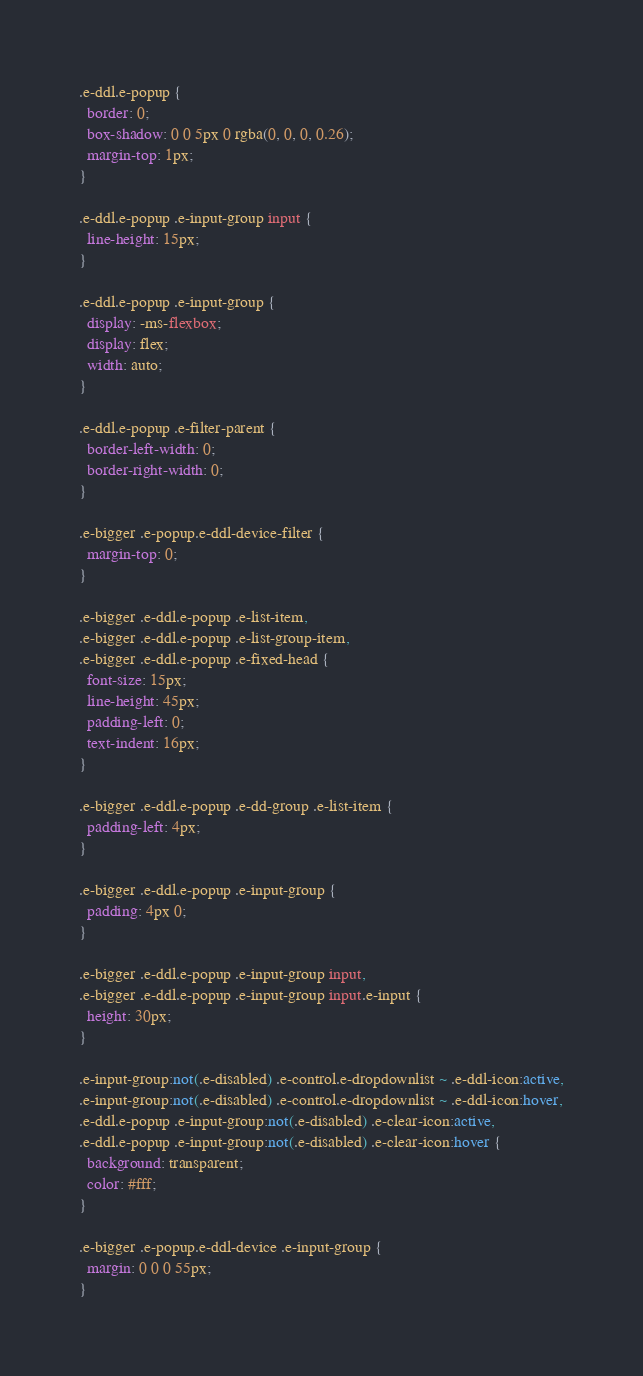Convert code to text. <code><loc_0><loc_0><loc_500><loc_500><_CSS_>.e-ddl.e-popup {
  border: 0;
  box-shadow: 0 0 5px 0 rgba(0, 0, 0, 0.26);
  margin-top: 1px;
}

.e-ddl.e-popup .e-input-group input {
  line-height: 15px;
}

.e-ddl.e-popup .e-input-group {
  display: -ms-flexbox;
  display: flex;
  width: auto;
}

.e-ddl.e-popup .e-filter-parent {
  border-left-width: 0;
  border-right-width: 0;
}

.e-bigger .e-popup.e-ddl-device-filter {
  margin-top: 0;
}

.e-bigger .e-ddl.e-popup .e-list-item,
.e-bigger .e-ddl.e-popup .e-list-group-item,
.e-bigger .e-ddl.e-popup .e-fixed-head {
  font-size: 15px;
  line-height: 45px;
  padding-left: 0;
  text-indent: 16px;
}

.e-bigger .e-ddl.e-popup .e-dd-group .e-list-item {
  padding-left: 4px;
}

.e-bigger .e-ddl.e-popup .e-input-group {
  padding: 4px 0;
}

.e-bigger .e-ddl.e-popup .e-input-group input,
.e-bigger .e-ddl.e-popup .e-input-group input.e-input {
  height: 30px;
}

.e-input-group:not(.e-disabled) .e-control.e-dropdownlist ~ .e-ddl-icon:active,
.e-input-group:not(.e-disabled) .e-control.e-dropdownlist ~ .e-ddl-icon:hover,
.e-ddl.e-popup .e-input-group:not(.e-disabled) .e-clear-icon:active,
.e-ddl.e-popup .e-input-group:not(.e-disabled) .e-clear-icon:hover {
  background: transparent;
  color: #fff;
}

.e-bigger .e-popup.e-ddl-device .e-input-group {
  margin: 0 0 0 55px;
}
</code> 